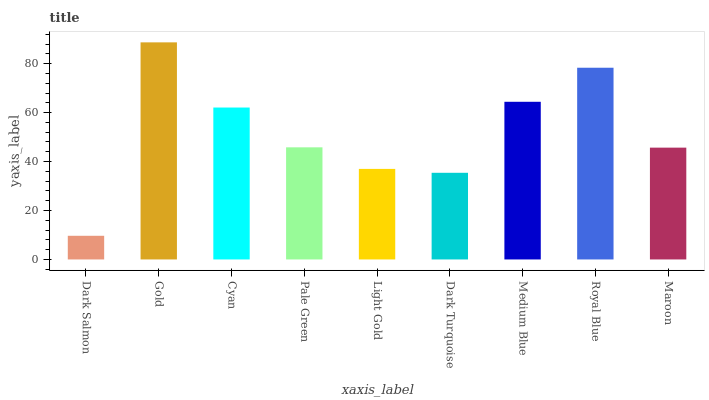Is Cyan the minimum?
Answer yes or no. No. Is Cyan the maximum?
Answer yes or no. No. Is Gold greater than Cyan?
Answer yes or no. Yes. Is Cyan less than Gold?
Answer yes or no. Yes. Is Cyan greater than Gold?
Answer yes or no. No. Is Gold less than Cyan?
Answer yes or no. No. Is Pale Green the high median?
Answer yes or no. Yes. Is Pale Green the low median?
Answer yes or no. Yes. Is Cyan the high median?
Answer yes or no. No. Is Maroon the low median?
Answer yes or no. No. 